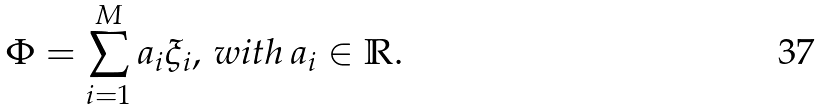<formula> <loc_0><loc_0><loc_500><loc_500>\Phi = \sum _ { i = 1 } ^ { M } a _ { i } \xi _ { i } , \, w i t h \, a _ { i } \in \mathbb { R } .</formula> 